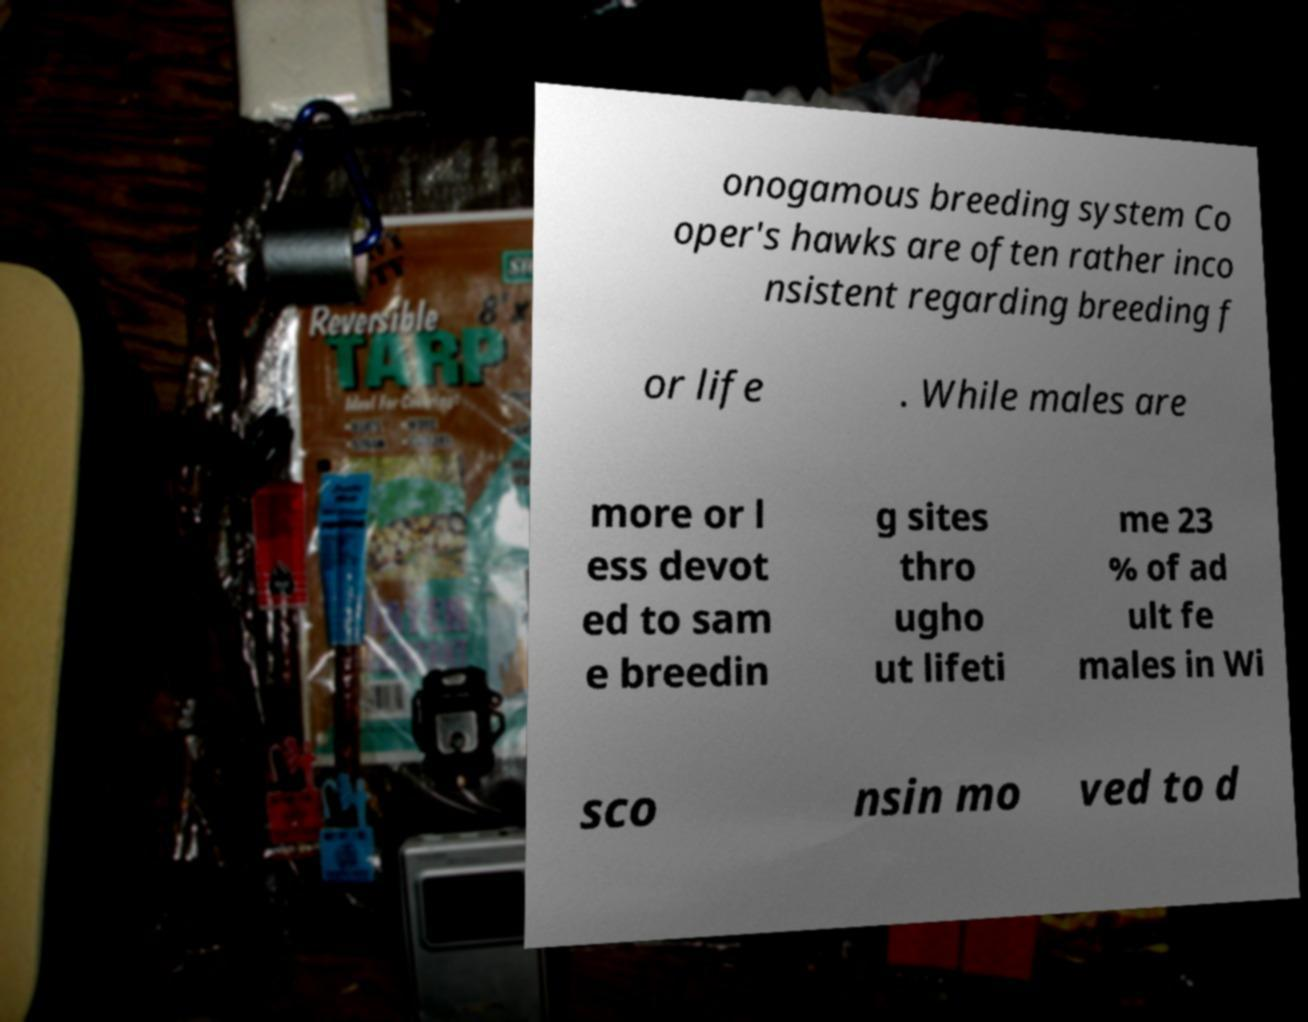For documentation purposes, I need the text within this image transcribed. Could you provide that? onogamous breeding system Co oper's hawks are often rather inco nsistent regarding breeding f or life . While males are more or l ess devot ed to sam e breedin g sites thro ugho ut lifeti me 23 % of ad ult fe males in Wi sco nsin mo ved to d 